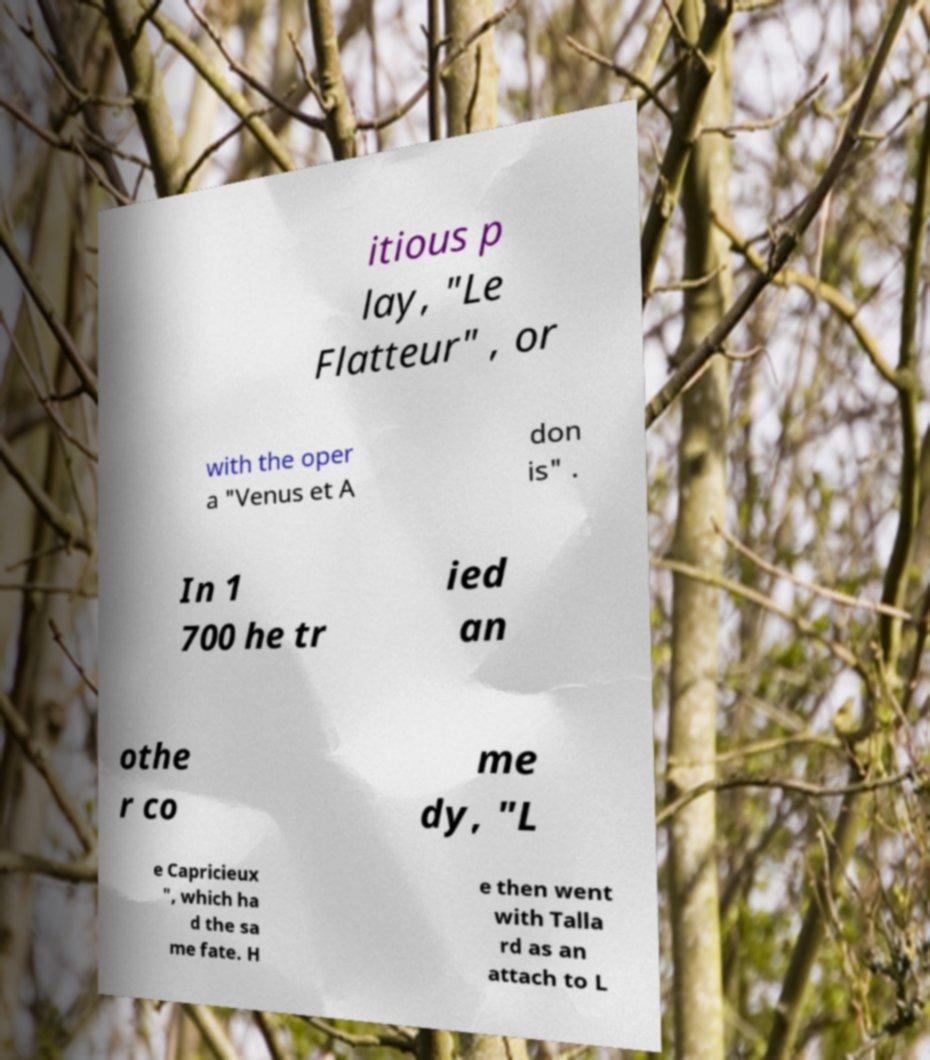Could you extract and type out the text from this image? itious p lay, "Le Flatteur" , or with the oper a "Venus et A don is" . In 1 700 he tr ied an othe r co me dy, "L e Capricieux ", which ha d the sa me fate. H e then went with Talla rd as an attach to L 